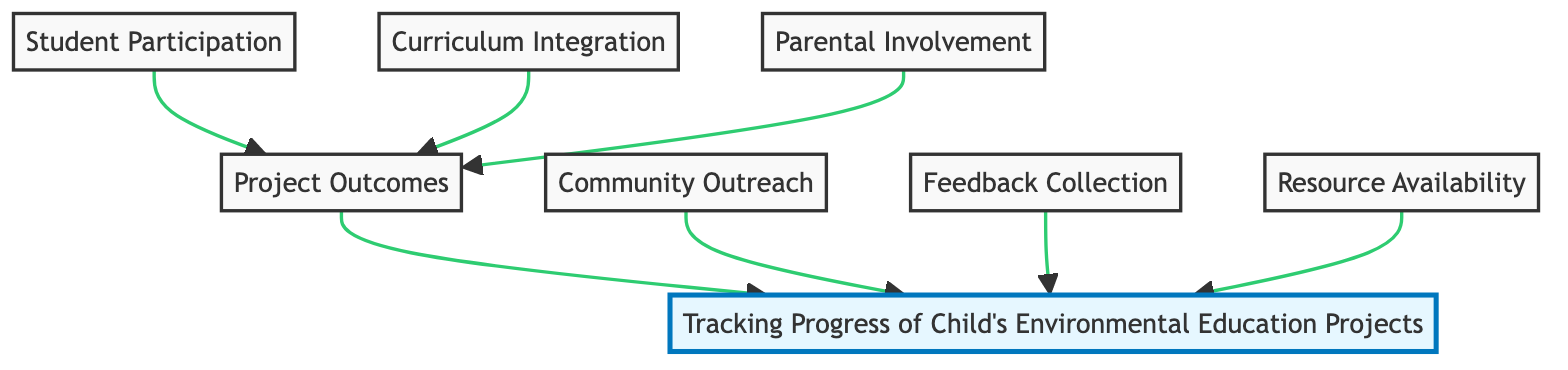What is the main topic of this flow chart? The title at the top of the chart clearly indicates that the main topic is "Tracking Progress of Child's Environmental Education Projects." Therefore, this title summarizes the focus of the entire diagram.
Answer: Tracking Progress of Child's Environmental Education Projects How many elements are there in the diagram? The diagram contains seven distinct elements, which represent different aspects related to environmental education projects at school. These elements are Student Participation, Curriculum Integration, Parental Involvement, Project Outcomes, Community Outreach, Feedback Collection, and Resource Availability.
Answer: Seven Which nodes contribute directly to Project Outcomes? The nodes that feed into Project Outcomes include Student Participation, Curriculum Integration, Parental Involvement, and Resource Availability, as they are all directly connected to this node in the flow.
Answer: Student Participation, Curriculum Integration, Parental Involvement What does the node "Feedback Collection" link to? Feedback Collection is a node that contributes to the overall tracking of child’s environmental education projects, linking directly to the main topic represented in the top node of the diagram. Thus, it plays a role in evaluating overall progress.
Answer: Tracking Progress of Child's Environmental Education Projects Which element assesses the availability of educational materials? The element that focuses specifically on this aspect is Resource Availability, which evaluates whether there are sufficient materials and resources to support effective environmental education in the school curriculum.
Answer: Resource Availability What is the relationship between Community Outreach and the main topic? Community Outreach is linked to the main topic through a direct connection, indicating that measuring community engagement in environmental initiatives is an integral part of tracking the overall progress of environmental education projects at the school.
Answer: Contributes to the main topic If student participation increases, which outcome is affected? If student participation increases, it positively impacts Project Outcomes, suggesting that active involvement from students is essential for achieving successful results in environmental education initiatives in the school.
Answer: Project Outcomes 